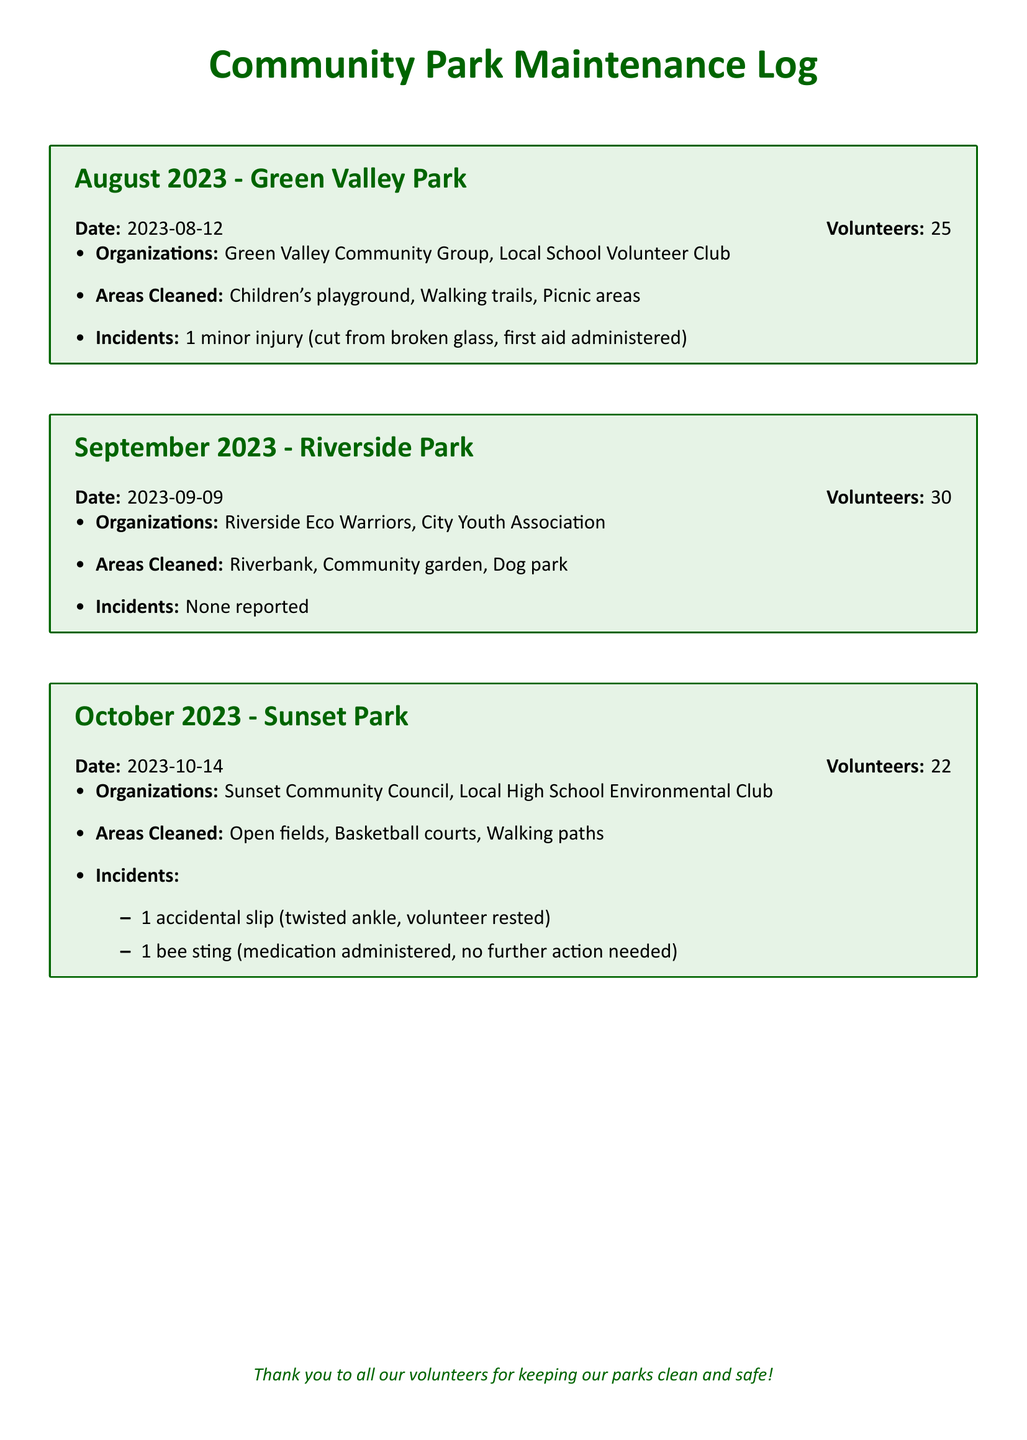what was the date of the August 2023 clean-up? The date of the August 2023 clean-up is specified in the document.
Answer: 2023-08-12 how many volunteers participated in the September 2023 event? The number of volunteers is mentioned in the log for September 2023.
Answer: 30 which organization was involved in the October 2023 clean-up? The organizations are listed under the October 2023 section.
Answer: Sunset Community Council what areas were cleaned in Green Valley Park? The areas cleaned are specified under the August 2023 entry.
Answer: Children's playground, Walking trails, Picnic areas were there any incidents reported in Riverside Park? The document explicitly states if any incidents occurred during the clean-up in Riverside Park.
Answer: None reported what type of injury occurred during the October 2023 event? The type of incidents is detailed in the October 2023 section.
Answer: twisted ankle which park was cleaned on September 9, 2023? The specific park is mentioned in the context of the clean-up event date.
Answer: Riverside Park how many organizations participated in the August 2023 park clean-up? The number of organizations involved is mentioned in the August 2023 entry.
Answer: 2 what area was cleaned in Sunset Park? The areas cleaned in Sunset Park are listed in the October 2023 section.
Answer: Open fields, Basketball courts, Walking paths 